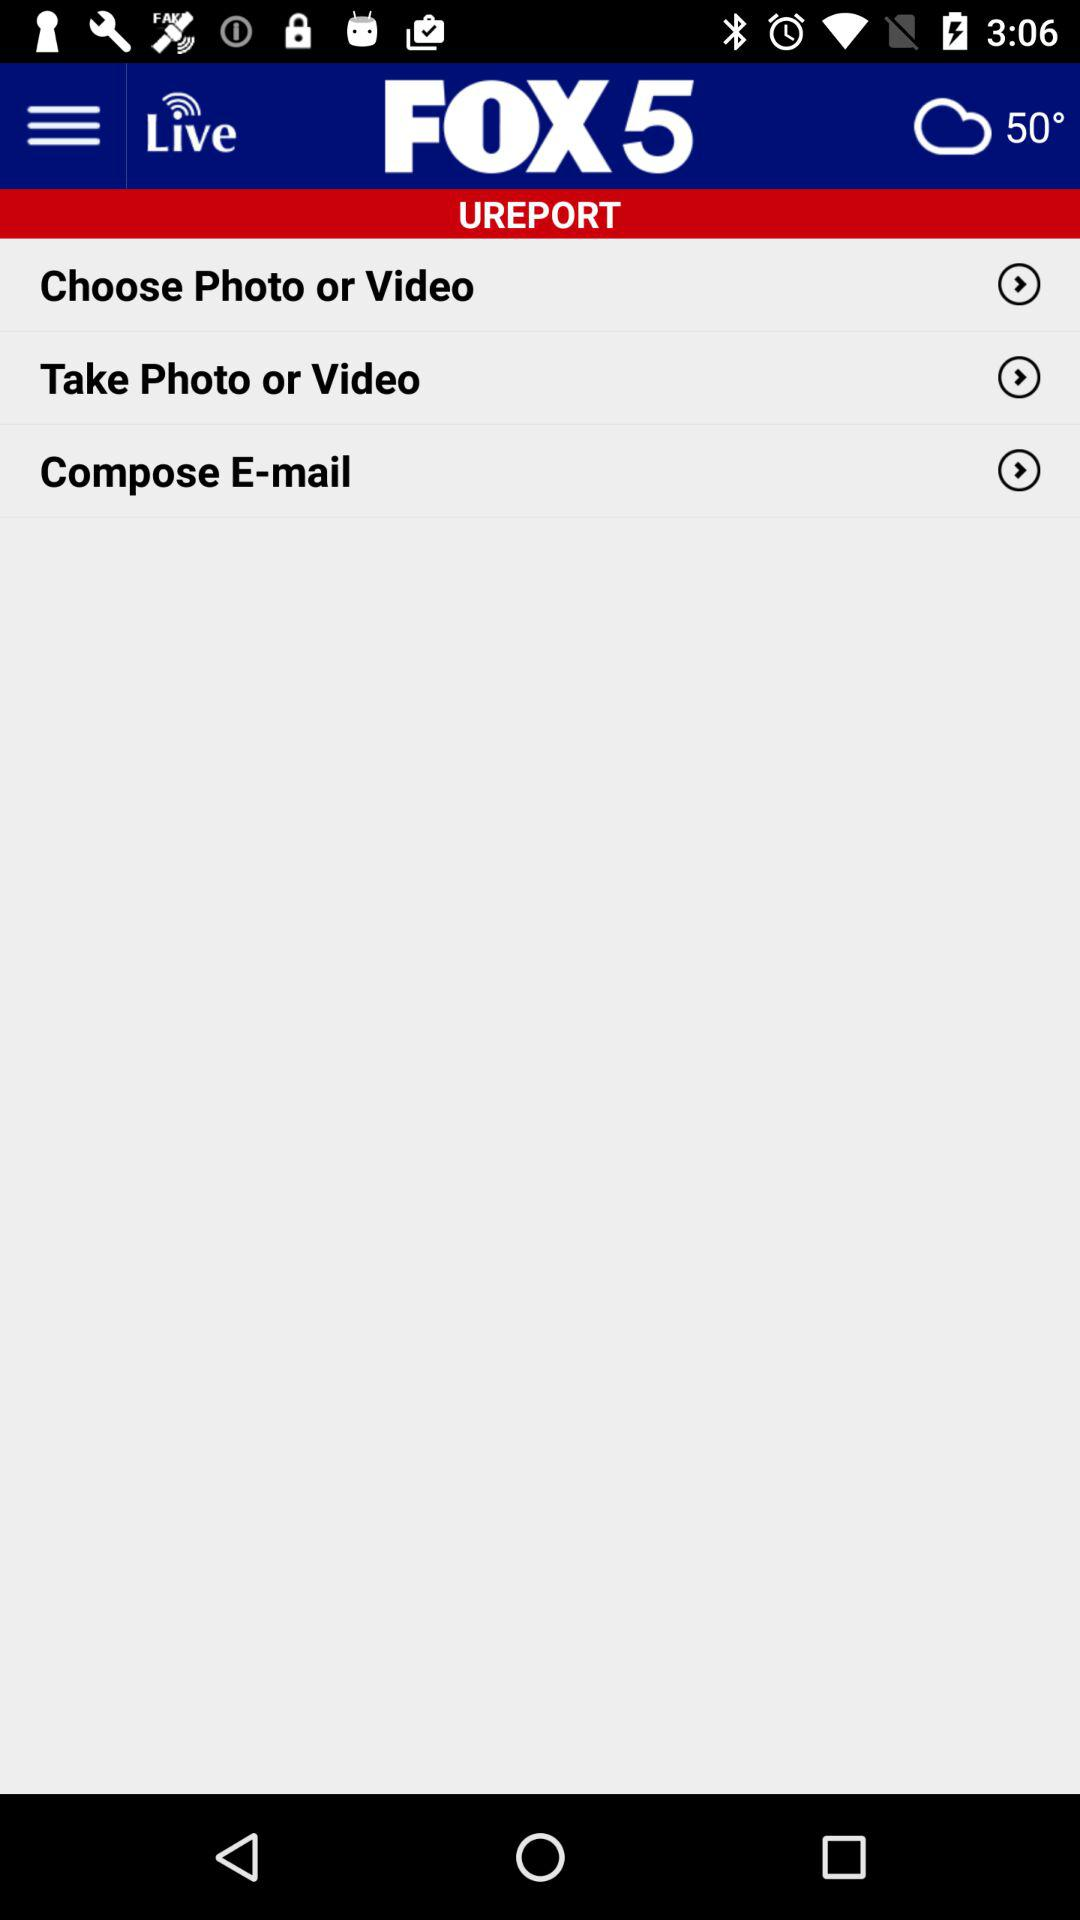What is the media house's name? The media house's name is "FOX 5". 